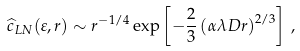<formula> <loc_0><loc_0><loc_500><loc_500>\widehat { c } _ { L N } ( \varepsilon , r ) \sim r ^ { - 1 / 4 } \exp \left [ - \frac { 2 } { 3 } \left ( \alpha \lambda D r \right ) ^ { 2 / 3 } \right ] \, ,</formula> 